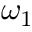Convert formula to latex. <formula><loc_0><loc_0><loc_500><loc_500>\omega _ { 1 }</formula> 